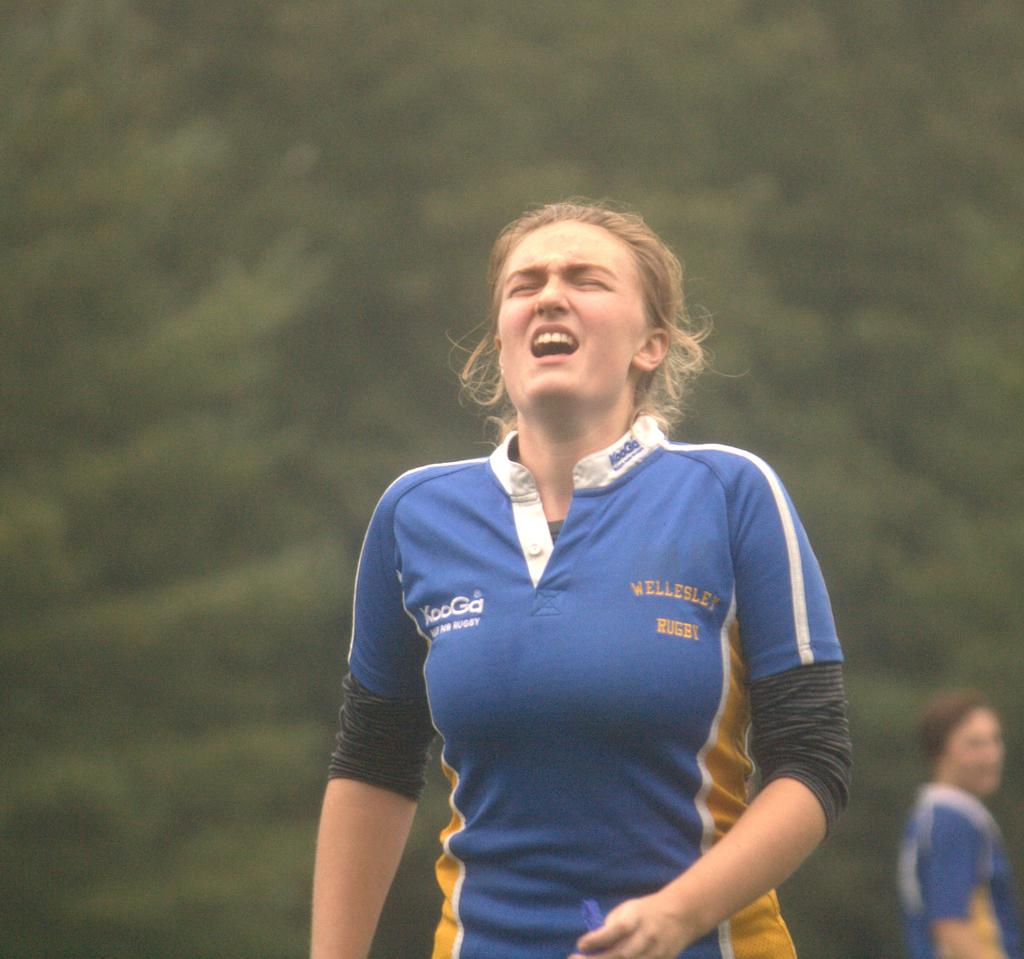Who is present in the image? There is a woman in the image. What is the woman wearing? The woman is wearing a rugby t-shirt. Are there any other people in the image? Yes, there is another person in the image. Can you describe the background of the image? The background of the image is unclear. What type of territory is being claimed by the woman in the image? There is no indication in the image that the woman is claiming any territory. 